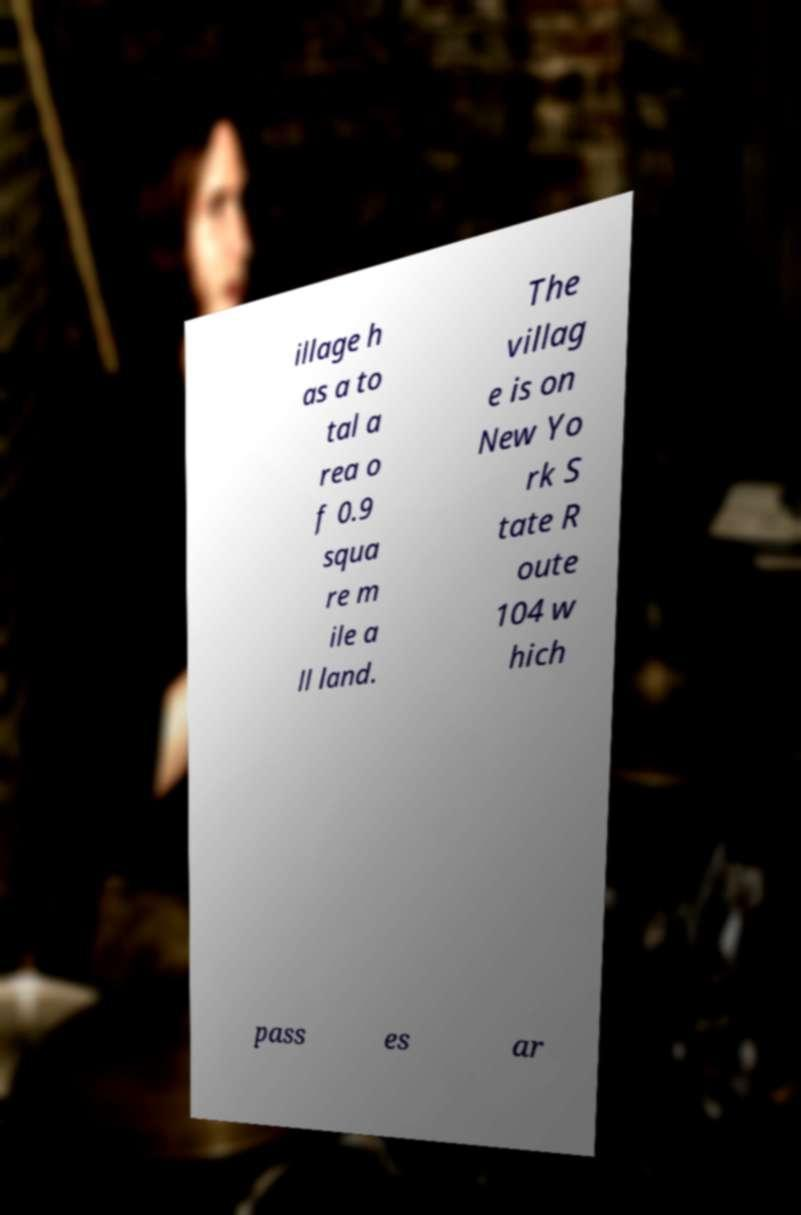Can you read and provide the text displayed in the image?This photo seems to have some interesting text. Can you extract and type it out for me? illage h as a to tal a rea o f 0.9 squa re m ile a ll land. The villag e is on New Yo rk S tate R oute 104 w hich pass es ar 